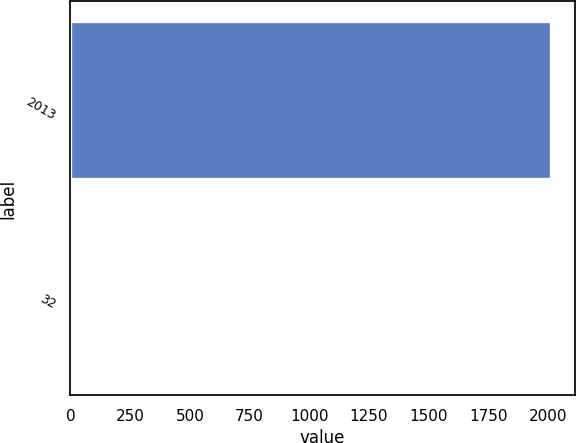Convert chart. <chart><loc_0><loc_0><loc_500><loc_500><bar_chart><fcel>2013<fcel>32<nl><fcel>2012<fcel>3.8<nl></chart> 